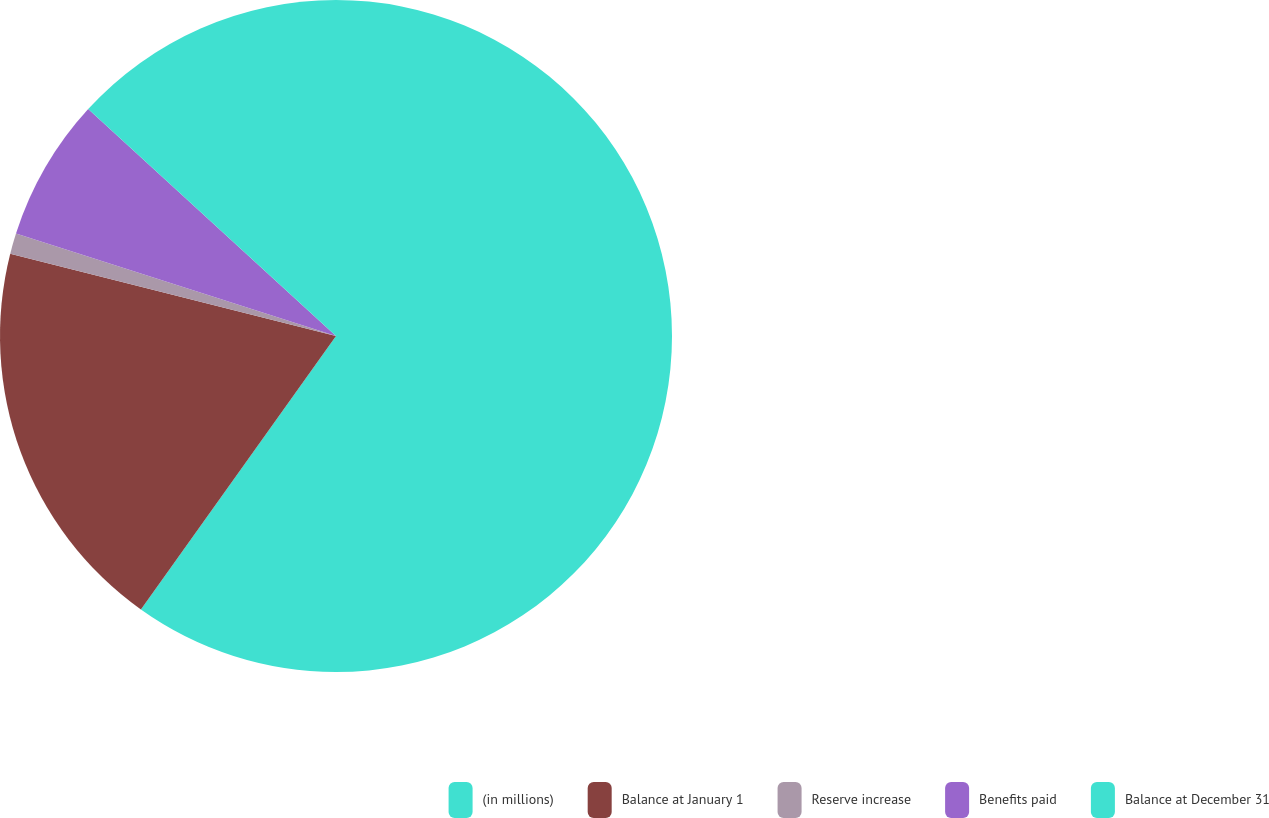Convert chart to OTSL. <chart><loc_0><loc_0><loc_500><loc_500><pie_chart><fcel>(in millions)<fcel>Balance at January 1<fcel>Reserve increase<fcel>Benefits paid<fcel>Balance at December 31<nl><fcel>59.86%<fcel>19.08%<fcel>0.99%<fcel>6.87%<fcel>13.2%<nl></chart> 